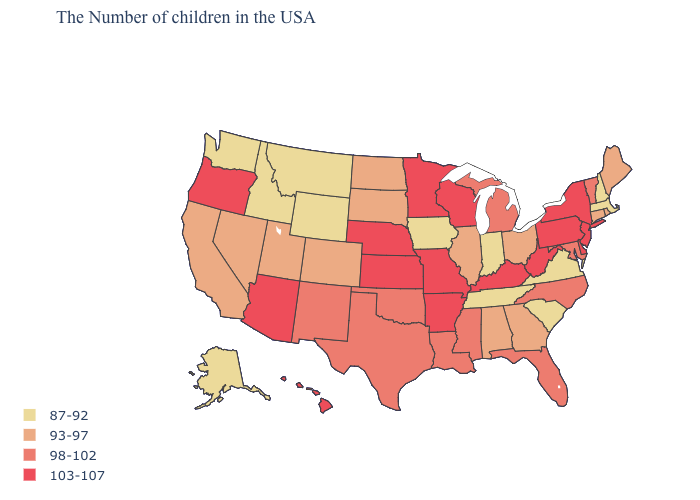Does the first symbol in the legend represent the smallest category?
Give a very brief answer. Yes. Does Kentucky have the highest value in the USA?
Concise answer only. Yes. What is the lowest value in the USA?
Quick response, please. 87-92. Which states have the highest value in the USA?
Give a very brief answer. New York, New Jersey, Delaware, Pennsylvania, West Virginia, Kentucky, Wisconsin, Missouri, Arkansas, Minnesota, Kansas, Nebraska, Arizona, Oregon, Hawaii. Which states have the lowest value in the MidWest?
Keep it brief. Indiana, Iowa. Name the states that have a value in the range 87-92?
Give a very brief answer. Massachusetts, New Hampshire, Virginia, South Carolina, Indiana, Tennessee, Iowa, Wyoming, Montana, Idaho, Washington, Alaska. Does the first symbol in the legend represent the smallest category?
Write a very short answer. Yes. How many symbols are there in the legend?
Keep it brief. 4. Does Tennessee have a higher value than California?
Write a very short answer. No. Does Arkansas have the highest value in the USA?
Write a very short answer. Yes. Does Kentucky have the lowest value in the USA?
Quick response, please. No. Does Utah have a higher value than Wyoming?
Give a very brief answer. Yes. Name the states that have a value in the range 87-92?
Give a very brief answer. Massachusetts, New Hampshire, Virginia, South Carolina, Indiana, Tennessee, Iowa, Wyoming, Montana, Idaho, Washington, Alaska. Does the map have missing data?
Give a very brief answer. No. What is the highest value in the Northeast ?
Write a very short answer. 103-107. 